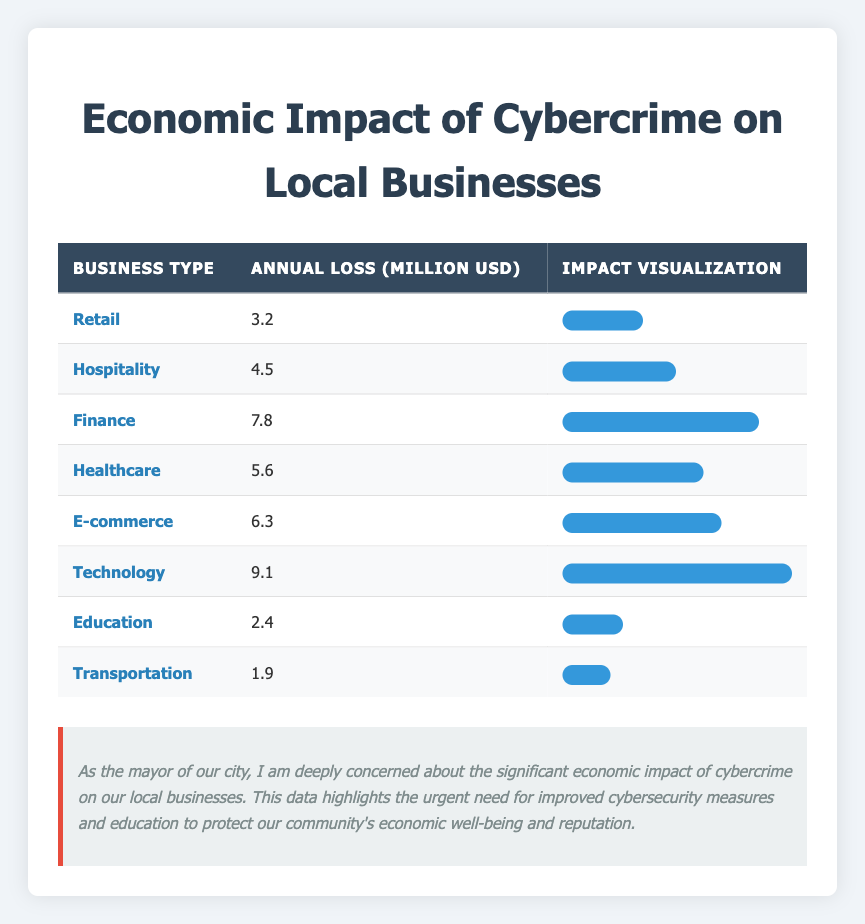What is the annual loss in million USD for the Technology sector due to cybercrime? From the table, the Technology sector has an annual loss of 9.1 million USD. This value is directly listed under the "Annual Loss (Million USD)" column for Technology.
Answer: 9.1 Which business type experiences the highest annual loss from cybercrime? Upon reviewing the table, the Technology sector shows the highest annual loss of 9.1 million USD, which is greater than the losses reported for other business types.
Answer: Technology What is the total annual loss from cybercrime across all listed business types? By adding the annual losses from each business type: 3.2 + 4.5 + 7.8 + 5.6 + 6.3 + 9.1 + 2.4 + 1.9, we get a total of 40.8 million USD. This is computed by summing up all the figures in the "Annual Loss (Million USD)" column.
Answer: 40.8 Does E-commerce incur more annual losses than Transportation due to cybercrime? Yes, the table shows that E-commerce has an annual loss of 6.3 million USD while Transportation has an annual loss of only 1.9 million USD. Therefore, E-commerce incurs more losses than Transportation.
Answer: Yes What is the average annual loss from cybercrime for the Healthcare and Hospitality sectors? First, sum the losses for both sectors: 5.6 (Healthcare) + 4.5 (Hospitality) = 10.1 million USD. Since there are two sectors, the average is 10.1 / 2 = 5.05 million USD. This means we total the values and then divide by the number of sectors assessed.
Answer: 5.05 Is the total annual loss for Education and Transportation greater than that of Finance? No, the total for Education is 2.4 million USD and for Transportation is 1.9 million USD, giving a combined total of 4.3 million USD. Finance has an annual loss of 7.8 million USD, which is greater than 4.3 million USD from Education and Transportation combined.
Answer: No What percentage of the total annual loss does the Finance sector represent? Finance's annual loss is 7.8 million USD. To find the percentage, use the formula (7.8 / 40.8) * 100, which results in approximately 19.12%. This ratio indicates how much Finance contributes to the overall losses.
Answer: 19.12% Which sectors have losses greater than 5 million USD? The sectors with losses exceeding 5 million USD are Finance (7.8 million USD), Healthcare (5.6 million USD), E-commerce (6.3 million USD), and Technology (9.1 million USD). This requires checking the values for specifically those business types.
Answer: Finance, Healthcare, E-commerce, Technology 